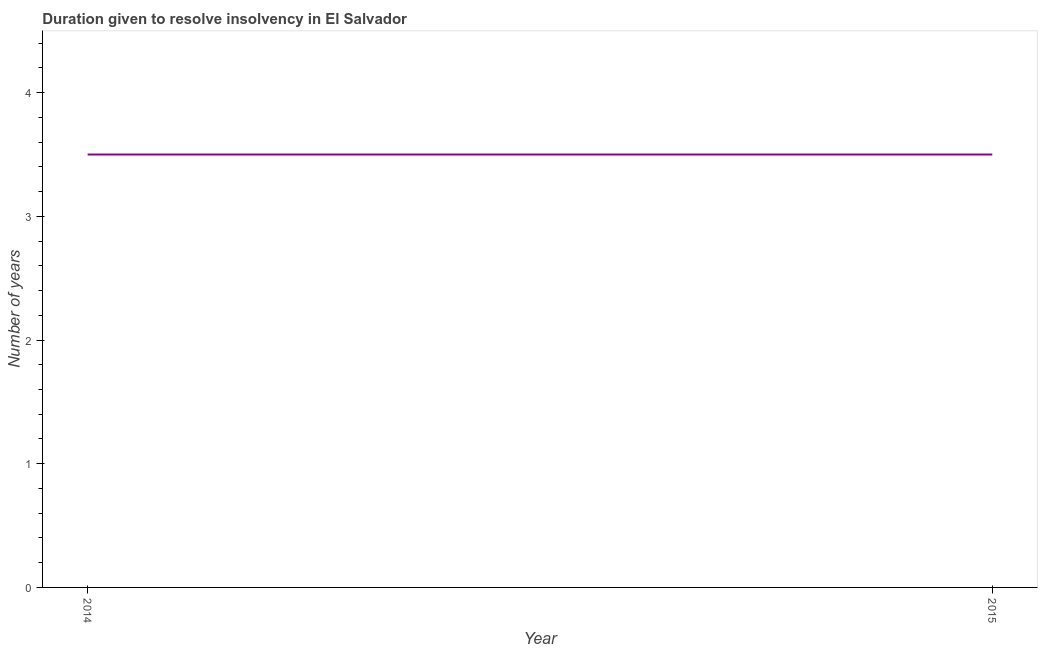What is the number of years to resolve insolvency in 2014?
Keep it short and to the point. 3.5. What is the sum of the number of years to resolve insolvency?
Keep it short and to the point. 7. What is the average number of years to resolve insolvency per year?
Provide a succinct answer. 3.5. Do a majority of the years between 2015 and 2014 (inclusive) have number of years to resolve insolvency greater than 3.6 ?
Make the answer very short. No. Does the number of years to resolve insolvency monotonically increase over the years?
Offer a very short reply. No. How many years are there in the graph?
Offer a very short reply. 2. What is the difference between two consecutive major ticks on the Y-axis?
Make the answer very short. 1. Does the graph contain grids?
Offer a terse response. No. What is the title of the graph?
Provide a succinct answer. Duration given to resolve insolvency in El Salvador. What is the label or title of the Y-axis?
Your answer should be compact. Number of years. What is the Number of years of 2014?
Make the answer very short. 3.5. What is the Number of years in 2015?
Give a very brief answer. 3.5. 